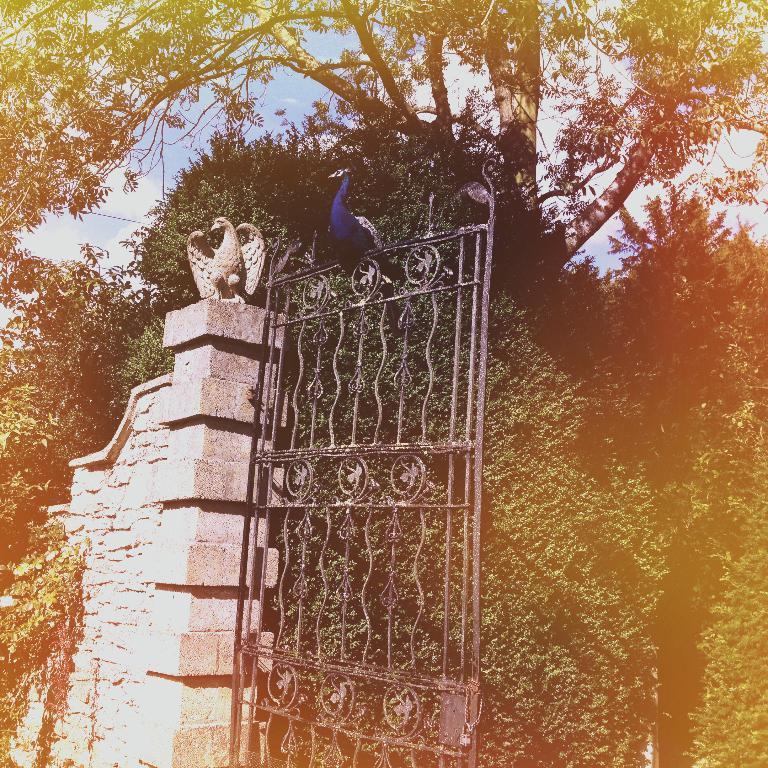How would you summarize this image in a sentence or two? In the center of the image, we can see a bird on the gate and we can see a sculpture on the wall. In the background, there are trees and there is sky. 